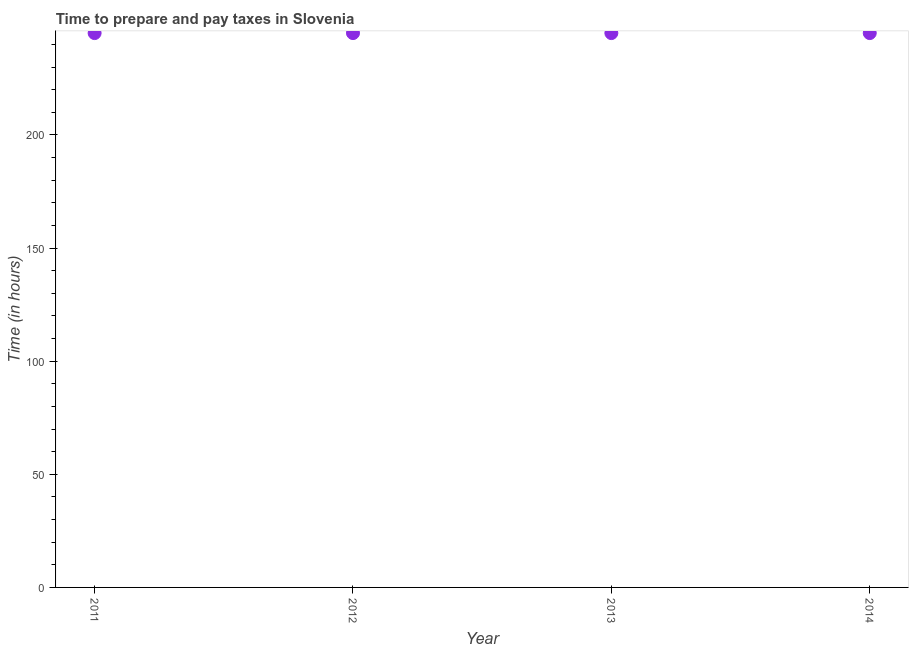What is the time to prepare and pay taxes in 2011?
Make the answer very short. 245. Across all years, what is the maximum time to prepare and pay taxes?
Give a very brief answer. 245. Across all years, what is the minimum time to prepare and pay taxes?
Your answer should be compact. 245. In which year was the time to prepare and pay taxes maximum?
Your answer should be compact. 2011. What is the sum of the time to prepare and pay taxes?
Make the answer very short. 980. What is the difference between the time to prepare and pay taxes in 2011 and 2012?
Give a very brief answer. 0. What is the average time to prepare and pay taxes per year?
Keep it short and to the point. 245. What is the median time to prepare and pay taxes?
Your response must be concise. 245. Is the difference between the time to prepare and pay taxes in 2012 and 2013 greater than the difference between any two years?
Your response must be concise. Yes. What is the difference between the highest and the second highest time to prepare and pay taxes?
Make the answer very short. 0. Is the sum of the time to prepare and pay taxes in 2012 and 2013 greater than the maximum time to prepare and pay taxes across all years?
Keep it short and to the point. Yes. What is the difference between the highest and the lowest time to prepare and pay taxes?
Your answer should be compact. 0. In how many years, is the time to prepare and pay taxes greater than the average time to prepare and pay taxes taken over all years?
Your answer should be very brief. 0. How many years are there in the graph?
Ensure brevity in your answer.  4. Are the values on the major ticks of Y-axis written in scientific E-notation?
Your response must be concise. No. Does the graph contain grids?
Keep it short and to the point. No. What is the title of the graph?
Offer a terse response. Time to prepare and pay taxes in Slovenia. What is the label or title of the Y-axis?
Give a very brief answer. Time (in hours). What is the Time (in hours) in 2011?
Give a very brief answer. 245. What is the Time (in hours) in 2012?
Your answer should be compact. 245. What is the Time (in hours) in 2013?
Your answer should be very brief. 245. What is the Time (in hours) in 2014?
Ensure brevity in your answer.  245. What is the difference between the Time (in hours) in 2011 and 2012?
Offer a very short reply. 0. What is the difference between the Time (in hours) in 2011 and 2013?
Provide a succinct answer. 0. What is the difference between the Time (in hours) in 2012 and 2014?
Your response must be concise. 0. What is the ratio of the Time (in hours) in 2011 to that in 2012?
Make the answer very short. 1. What is the ratio of the Time (in hours) in 2011 to that in 2013?
Keep it short and to the point. 1. What is the ratio of the Time (in hours) in 2011 to that in 2014?
Your response must be concise. 1. What is the ratio of the Time (in hours) in 2012 to that in 2013?
Your response must be concise. 1. 